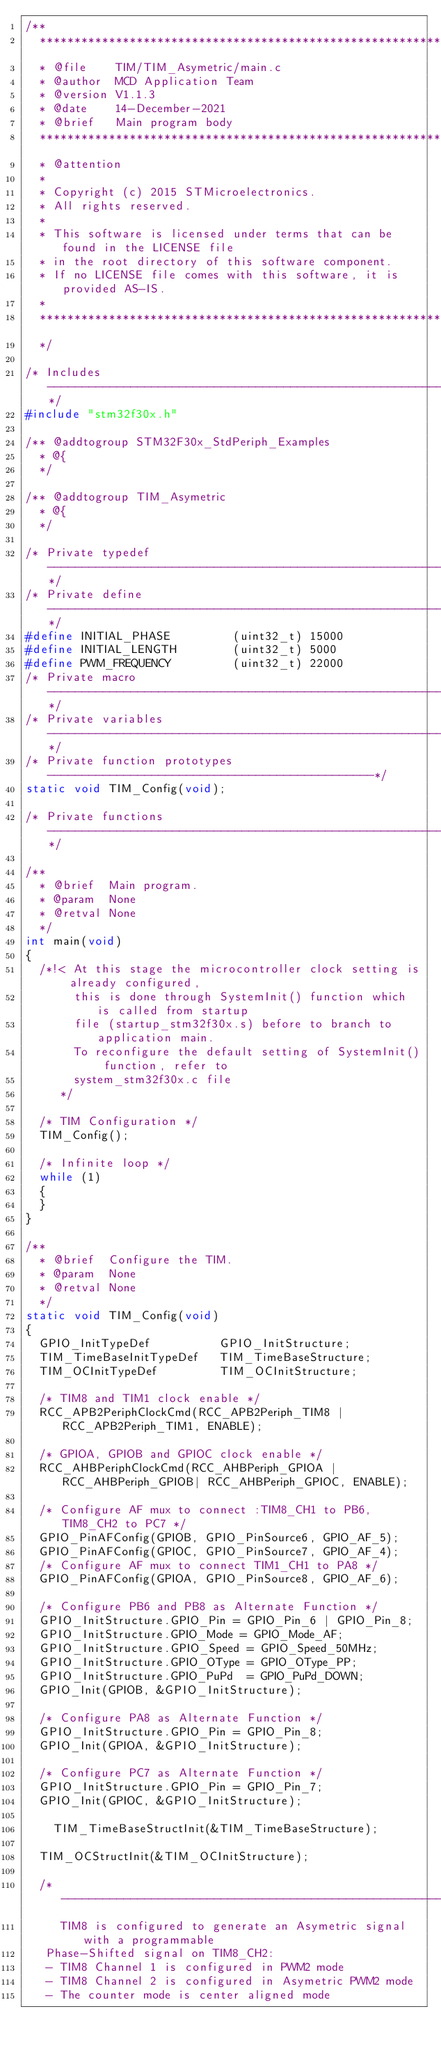<code> <loc_0><loc_0><loc_500><loc_500><_C_>/**
  ******************************************************************************
  * @file    TIM/TIM_Asymetric/main.c  
  * @author  MCD Application Team
  * @version V1.1.3
  * @date    14-December-2021
  * @brief   Main program body
  ******************************************************************************
  * @attention
  *
  * Copyright (c) 2015 STMicroelectronics.
  * All rights reserved.
  *
  * This software is licensed under terms that can be found in the LICENSE file
  * in the root directory of this software component.
  * If no LICENSE file comes with this software, it is provided AS-IS.
  *
  ******************************************************************************
  */

/* Includes ------------------------------------------------------------------*/
#include "stm32f30x.h"

/** @addtogroup STM32F30x_StdPeriph_Examples
  * @{
  */

/** @addtogroup TIM_Asymetric
  * @{
  */

/* Private typedef -----------------------------------------------------------*/
/* Private define ------------------------------------------------------------*/
#define INITIAL_PHASE         (uint32_t) 15000
#define INITIAL_LENGTH        (uint32_t) 5000
#define PWM_FREQUENCY         (uint32_t) 22000
/* Private macro -------------------------------------------------------------*/
/* Private variables ---------------------------------------------------------*/
/* Private function prototypes -----------------------------------------------*/
static void TIM_Config(void);

/* Private functions ---------------------------------------------------------*/

/**
  * @brief  Main program.
  * @param  None
  * @retval None
  */
int main(void)
{
  /*!< At this stage the microcontroller clock setting is already configured, 
       this is done through SystemInit() function which is called from startup
       file (startup_stm32f30x.s) before to branch to application main.
       To reconfigure the default setting of SystemInit() function, refer to
       system_stm32f30x.c file
     */ 

  /* TIM Configuration */
  TIM_Config();

  /* Infinite loop */
  while (1)
  {
  }
}

/**
  * @brief  Configure the TIM.
  * @param  None
  * @retval None
  */
static void TIM_Config(void)
{
  GPIO_InitTypeDef          GPIO_InitStructure;
  TIM_TimeBaseInitTypeDef   TIM_TimeBaseStructure;
  TIM_OCInitTypeDef         TIM_OCInitStructure;
  
  /* TIM8 and TIM1 clock enable */
  RCC_APB2PeriphClockCmd(RCC_APB2Periph_TIM8 | RCC_APB2Periph_TIM1, ENABLE);
  
  /* GPIOA, GPIOB and GPIOC clock enable */
  RCC_AHBPeriphClockCmd(RCC_AHBPeriph_GPIOA | RCC_AHBPeriph_GPIOB| RCC_AHBPeriph_GPIOC, ENABLE);
  
  /* Configure AF mux to connect :TIM8_CH1 to PB6, TIM8_CH2 to PC7 */
  GPIO_PinAFConfig(GPIOB, GPIO_PinSource6, GPIO_AF_5);
  GPIO_PinAFConfig(GPIOC, GPIO_PinSource7, GPIO_AF_4);
  /* Configure AF mux to connect TIM1_CH1 to PA8 */
  GPIO_PinAFConfig(GPIOA, GPIO_PinSource8, GPIO_AF_6);

  /* Configure PB6 and PB8 as Alternate Function */
  GPIO_InitStructure.GPIO_Pin = GPIO_Pin_6 | GPIO_Pin_8;
  GPIO_InitStructure.GPIO_Mode = GPIO_Mode_AF;
  GPIO_InitStructure.GPIO_Speed = GPIO_Speed_50MHz;
  GPIO_InitStructure.GPIO_OType = GPIO_OType_PP;
  GPIO_InitStructure.GPIO_PuPd  = GPIO_PuPd_DOWN;
  GPIO_Init(GPIOB, &GPIO_InitStructure);
  
  /* Configure PA8 as Alternate Function */
  GPIO_InitStructure.GPIO_Pin = GPIO_Pin_8;
  GPIO_Init(GPIOA, &GPIO_InitStructure); 
  
  /* Configure PC7 as Alternate Function */
  GPIO_InitStructure.GPIO_Pin = GPIO_Pin_7;
  GPIO_Init(GPIOC, &GPIO_InitStructure); 
  
    TIM_TimeBaseStructInit(&TIM_TimeBaseStructure);

  TIM_OCStructInit(&TIM_OCInitStructure);

  /* ---------------------------------------------------------------------------
     TIM8 is configured to generate an Asymetric signal with a programmable 
	 Phase-Shifted signal on TIM8_CH2:
	 - TIM8 Channel 1 is configured in PWM2 mode
	 - TIM8 Channel 2 is configured in Asymetric PWM2 mode
	 - The counter mode is center aligned mode</code> 